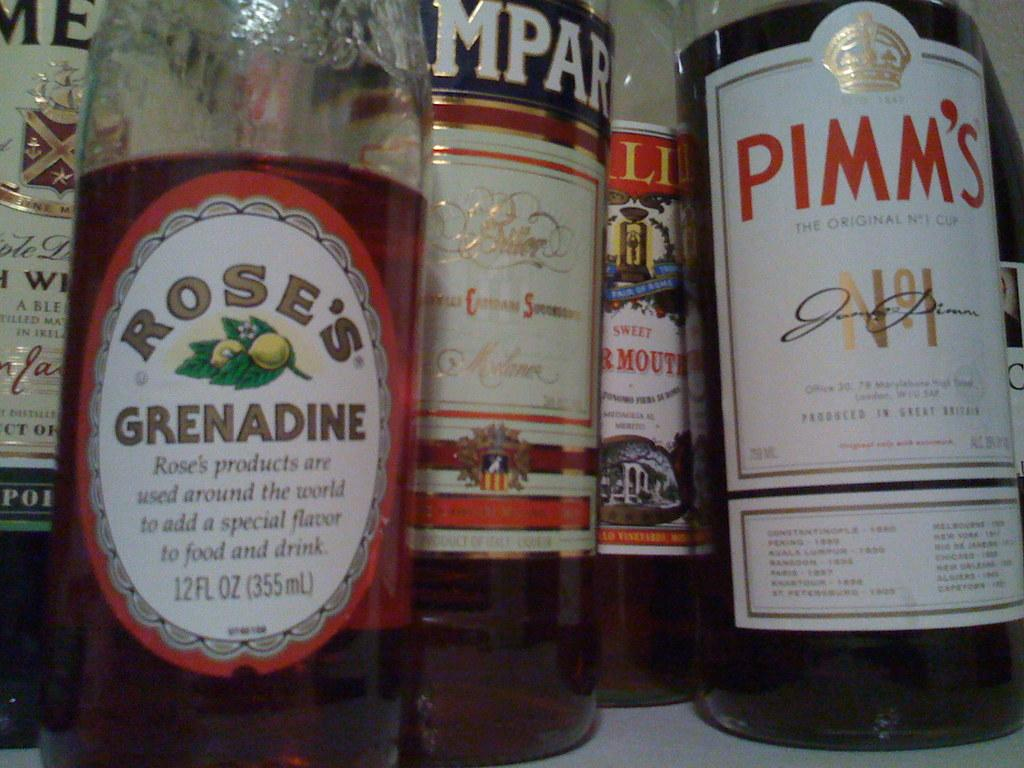<image>
Create a compact narrative representing the image presented. A bottle of Pimm's sits next to a bottle of Rose's Grenadine 